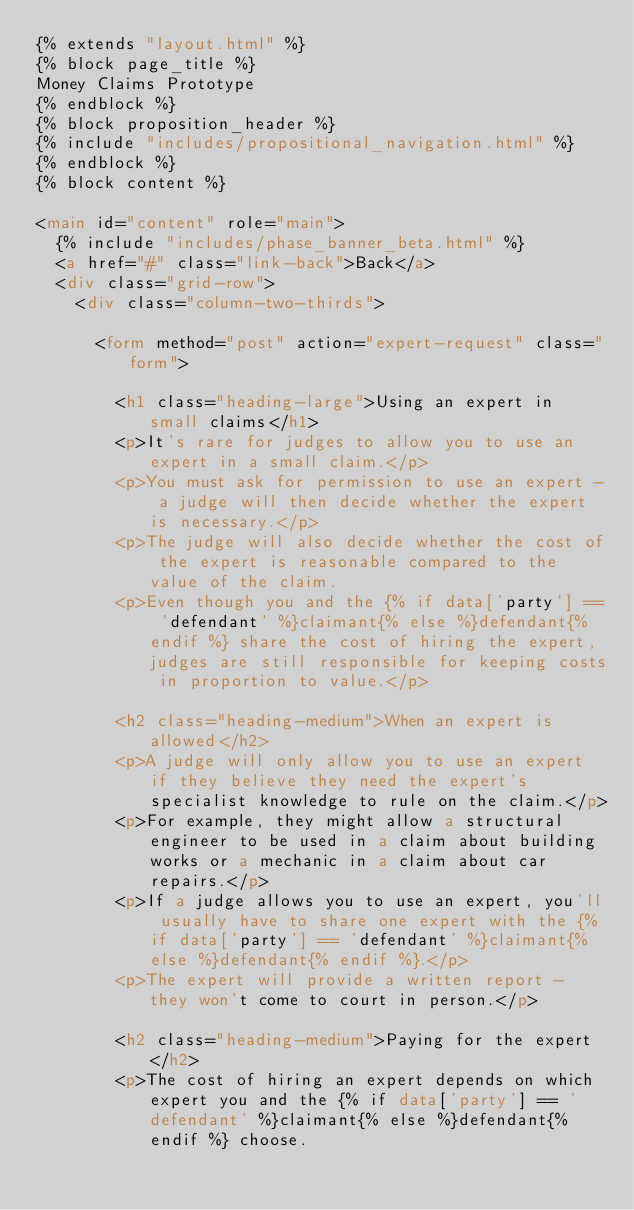<code> <loc_0><loc_0><loc_500><loc_500><_HTML_>{% extends "layout.html" %}
{% block page_title %}
Money Claims Prototype
{% endblock %}
{% block proposition_header %}
{% include "includes/propositional_navigation.html" %}
{% endblock %}
{% block content %}

<main id="content" role="main">
  {% include "includes/phase_banner_beta.html" %}
  <a href="#" class="link-back">Back</a>
  <div class="grid-row">
    <div class="column-two-thirds">

      <form method="post" action="expert-request" class="form">

        <h1 class="heading-large">Using an expert in small claims</h1>
        <p>It's rare for judges to allow you to use an expert in a small claim.</p>
        <p>You must ask for permission to use an expert - a judge will then decide whether the expert is necessary.</p>
        <p>The judge will also decide whether the cost of the expert is reasonable compared to the value of the claim.
        <p>Even though you and the {% if data['party'] == 'defendant' %}claimant{% else %}defendant{% endif %} share the cost of hiring the expert, judges are still responsible for keeping costs in proportion to value.</p>

        <h2 class="heading-medium">When an expert is allowed</h2>
        <p>A judge will only allow you to use an expert if they believe they need the expert's specialist knowledge to rule on the claim.</p>
        <p>For example, they might allow a structural engineer to be used in a claim about building works or a mechanic in a claim about car repairs.</p>
        <p>If a judge allows you to use an expert, you'll usually have to share one expert with the {% if data['party'] == 'defendant' %}claimant{% else %}defendant{% endif %}.</p>
        <p>The expert will provide a written report - they won't come to court in person.</p>

        <h2 class="heading-medium">Paying for the expert</h2>
        <p>The cost of hiring an expert depends on which expert you and the {% if data['party'] == 'defendant' %}claimant{% else %}defendant{% endif %} choose.</code> 